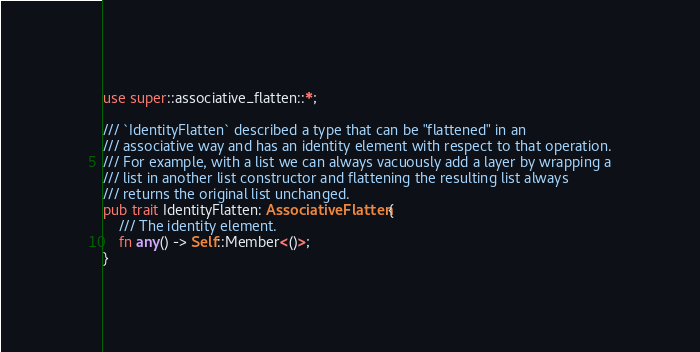Convert code to text. <code><loc_0><loc_0><loc_500><loc_500><_Rust_>use super::associative_flatten::*;

/// `IdentityFlatten` described a type that can be "flattened" in an
/// associative way and has an identity element with respect to that operation.
/// For example, with a list we can always vacuously add a layer by wrapping a
/// list in another list constructor and flattening the resulting list always
/// returns the original list unchanged.
pub trait IdentityFlatten: AssociativeFlatten {
    /// The identity element.
    fn any() -> Self::Member<()>;
}
</code> 